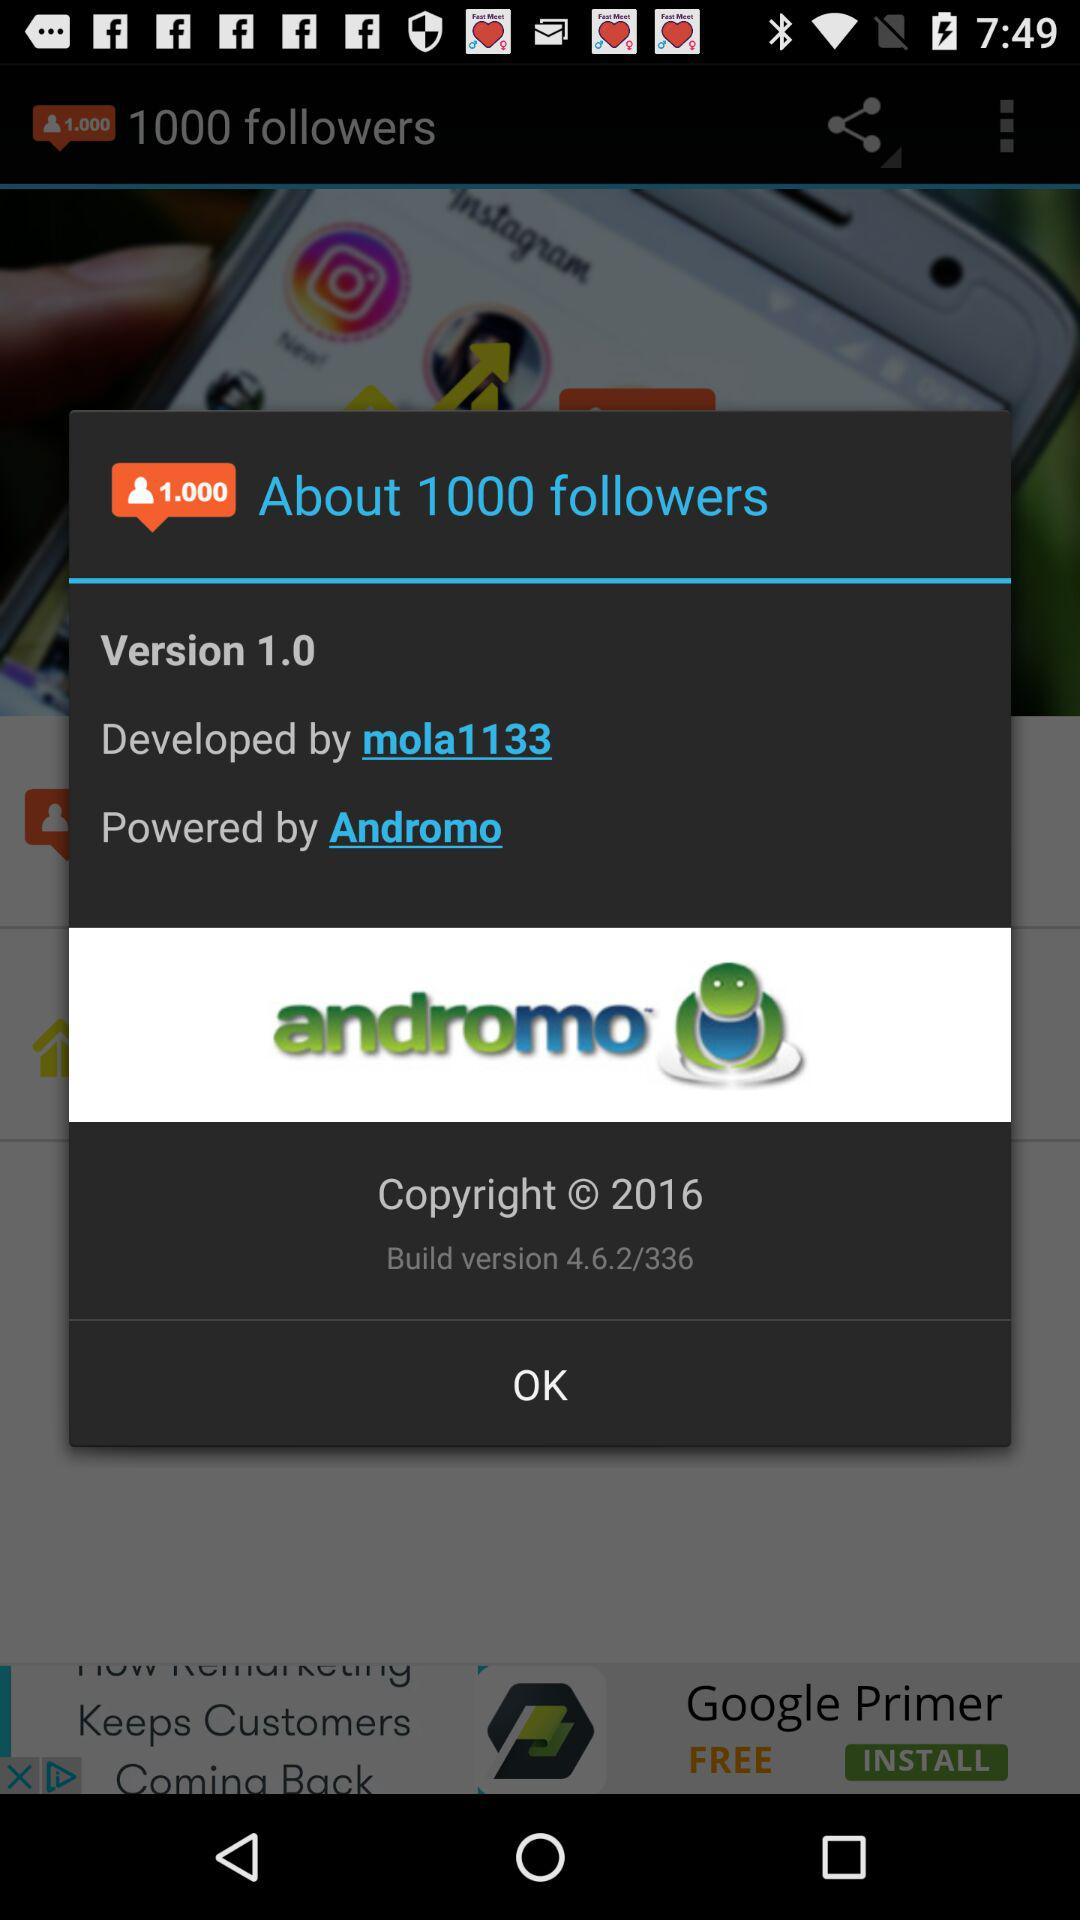What is the copyright year? The copyright year is 2016. 